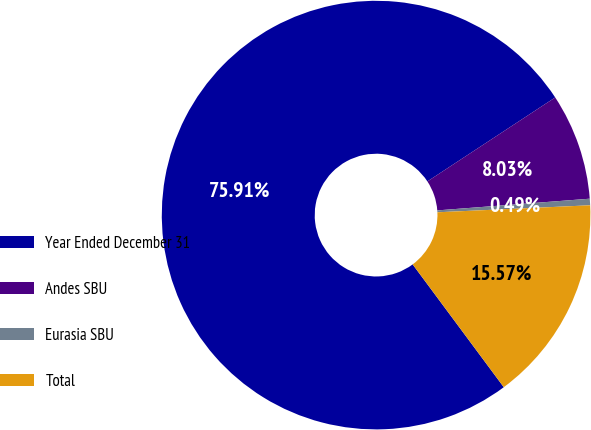<chart> <loc_0><loc_0><loc_500><loc_500><pie_chart><fcel>Year Ended December 31<fcel>Andes SBU<fcel>Eurasia SBU<fcel>Total<nl><fcel>75.91%<fcel>8.03%<fcel>0.49%<fcel>15.57%<nl></chart> 